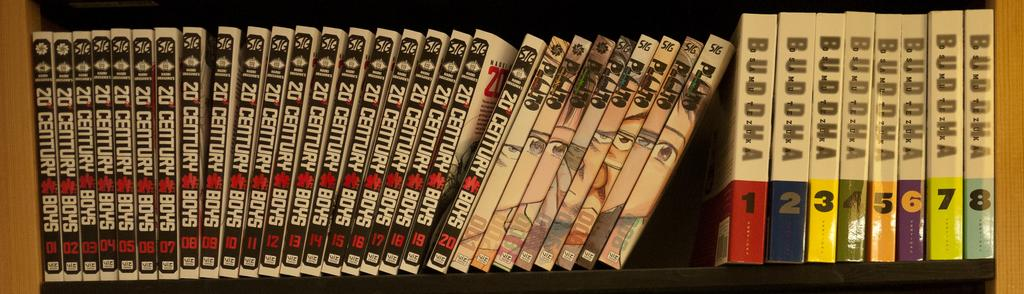<image>
Offer a succinct explanation of the picture presented. DVDs are lined up on a shelf including Buddha volumes 1-8. 